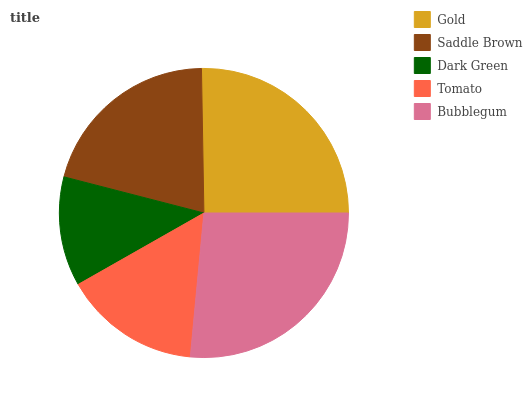Is Dark Green the minimum?
Answer yes or no. Yes. Is Bubblegum the maximum?
Answer yes or no. Yes. Is Saddle Brown the minimum?
Answer yes or no. No. Is Saddle Brown the maximum?
Answer yes or no. No. Is Gold greater than Saddle Brown?
Answer yes or no. Yes. Is Saddle Brown less than Gold?
Answer yes or no. Yes. Is Saddle Brown greater than Gold?
Answer yes or no. No. Is Gold less than Saddle Brown?
Answer yes or no. No. Is Saddle Brown the high median?
Answer yes or no. Yes. Is Saddle Brown the low median?
Answer yes or no. Yes. Is Tomato the high median?
Answer yes or no. No. Is Bubblegum the low median?
Answer yes or no. No. 